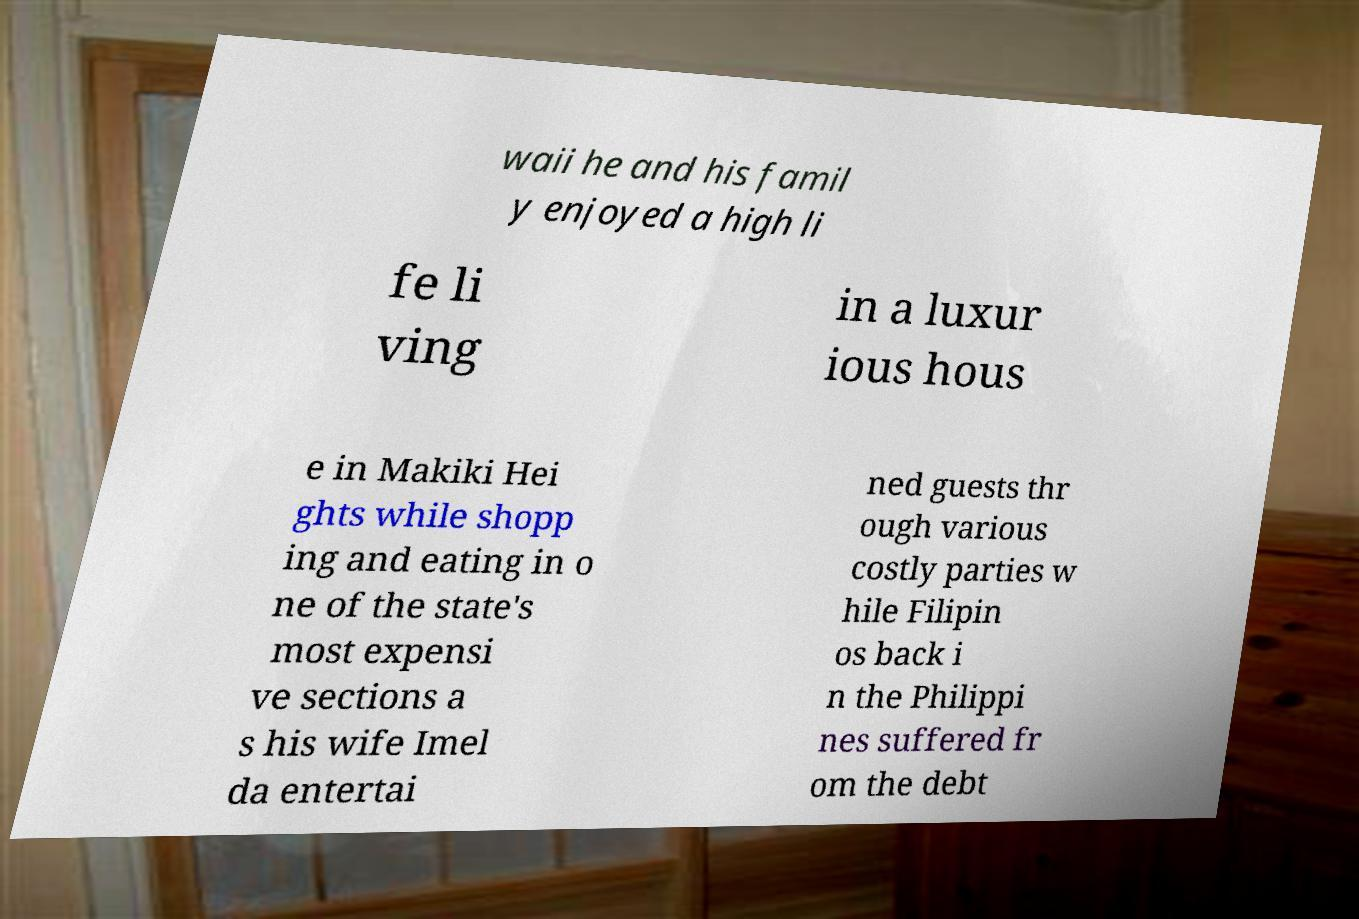Can you accurately transcribe the text from the provided image for me? waii he and his famil y enjoyed a high li fe li ving in a luxur ious hous e in Makiki Hei ghts while shopp ing and eating in o ne of the state's most expensi ve sections a s his wife Imel da entertai ned guests thr ough various costly parties w hile Filipin os back i n the Philippi nes suffered fr om the debt 